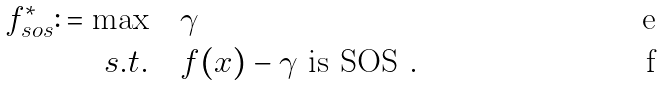Convert formula to latex. <formula><loc_0><loc_0><loc_500><loc_500>f ^ { * } _ { s o s } \colon = \max & \quad \gamma \\ s . t . & \quad f ( x ) - \gamma \text { is SOS } .</formula> 